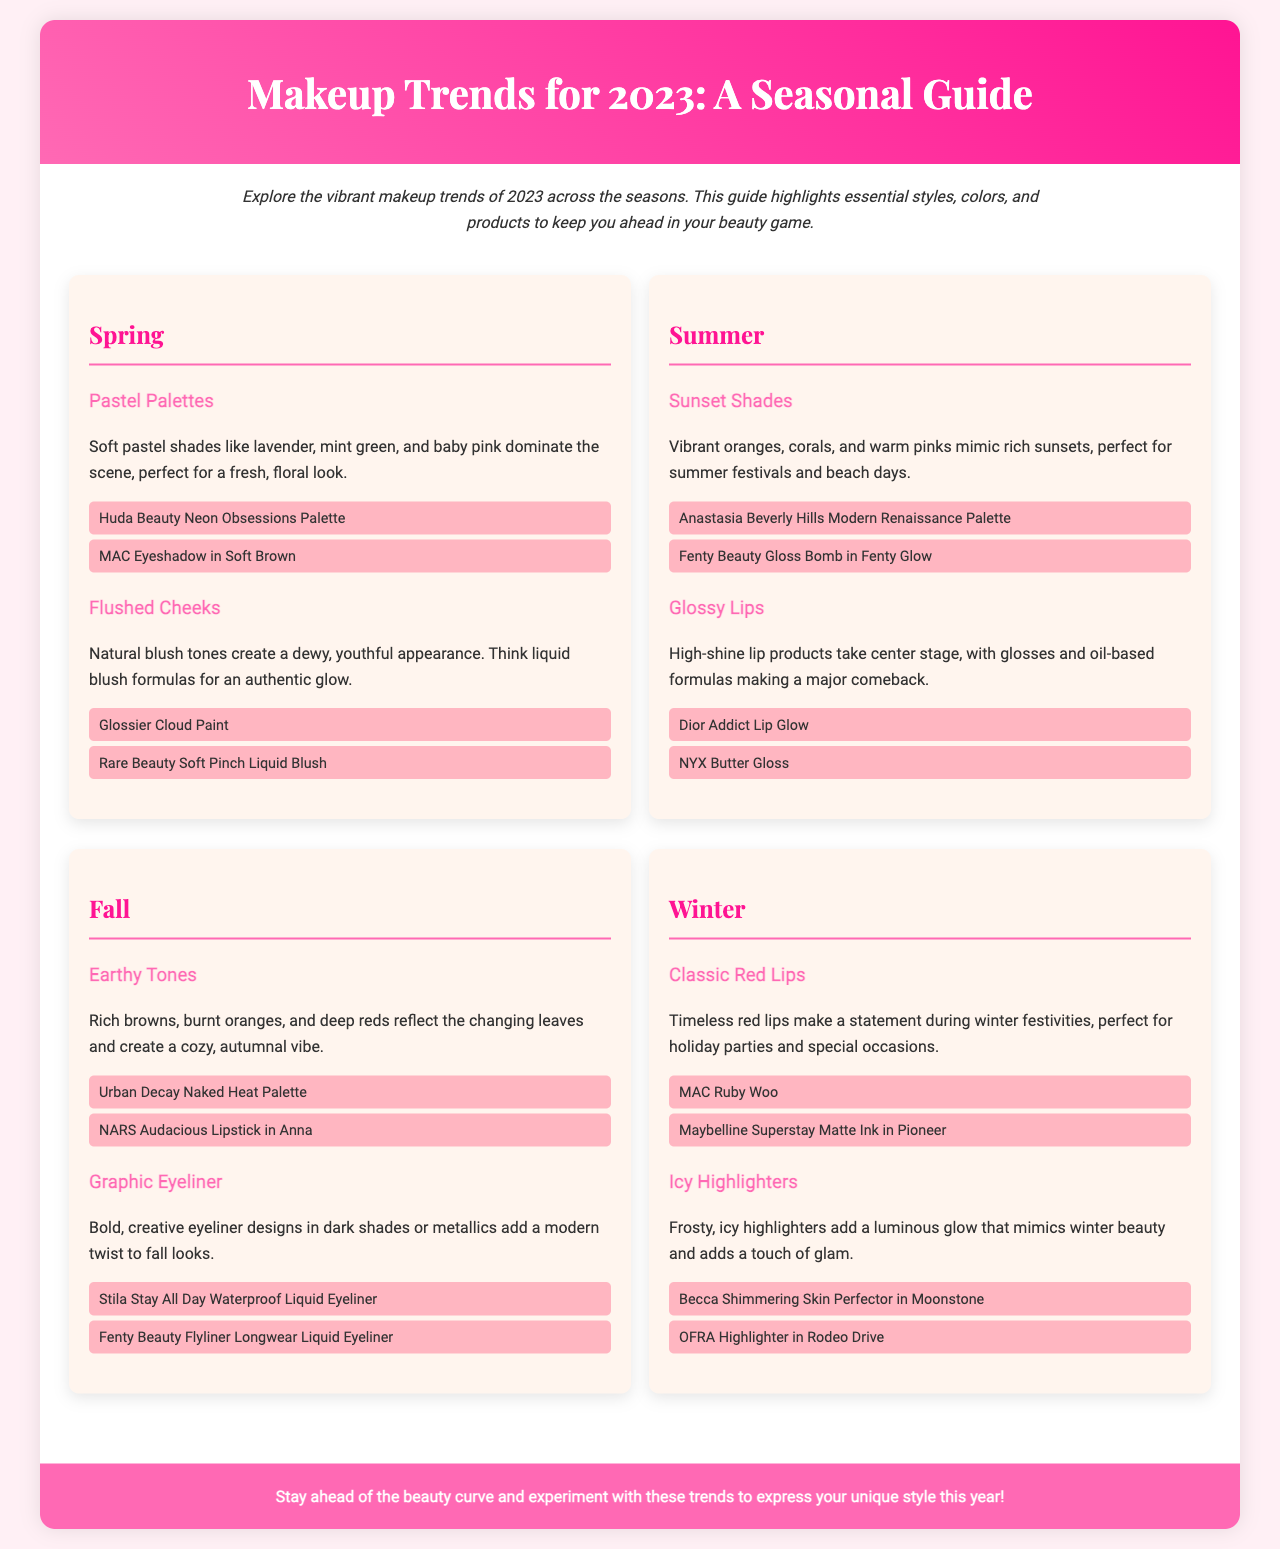what are the primary colors for spring makeup trends? The spring makeup trend emphasizes soft pastel shades, specifically mentioning lavender, mint green, and baby pink.
Answer: lavender, mint green, baby pink which brand offers a liquid blush mentioned in the spring section? The document lists Glossier Cloud Paint and Rare Beauty Soft Pinch Liquid Blush as liquid blush options for spring.
Answer: Glossier what makeup trend features vibrant oranges and corals? This trend is listed under summer, where vibrant oranges and corals are highlighted as sunset shades.
Answer: sunset shades which product is recommended for classic red lips in winter? The document specifically mentions MAC Ruby Woo for classic red lips in the winter section.
Answer: MAC Ruby Woo how many seasons are covered in the guide? The guide outlines makeup trends for four distinct seasons: spring, summer, fall, and winter.
Answer: four what highlighter trend is suggested for winter? The winter trend suggests using icy highlighters to achieve a luminous glow.
Answer: icy highlighters which eyeliner style is trendy for fall? The fall section describes graphic eyeliner as a bold, creative style to incorporate.
Answer: graphic eyeliner what is the main focus of the guide? The document's introduction indicates a focus on exploring vibrant makeup trends for different seasons.
Answer: vibrant makeup trends 